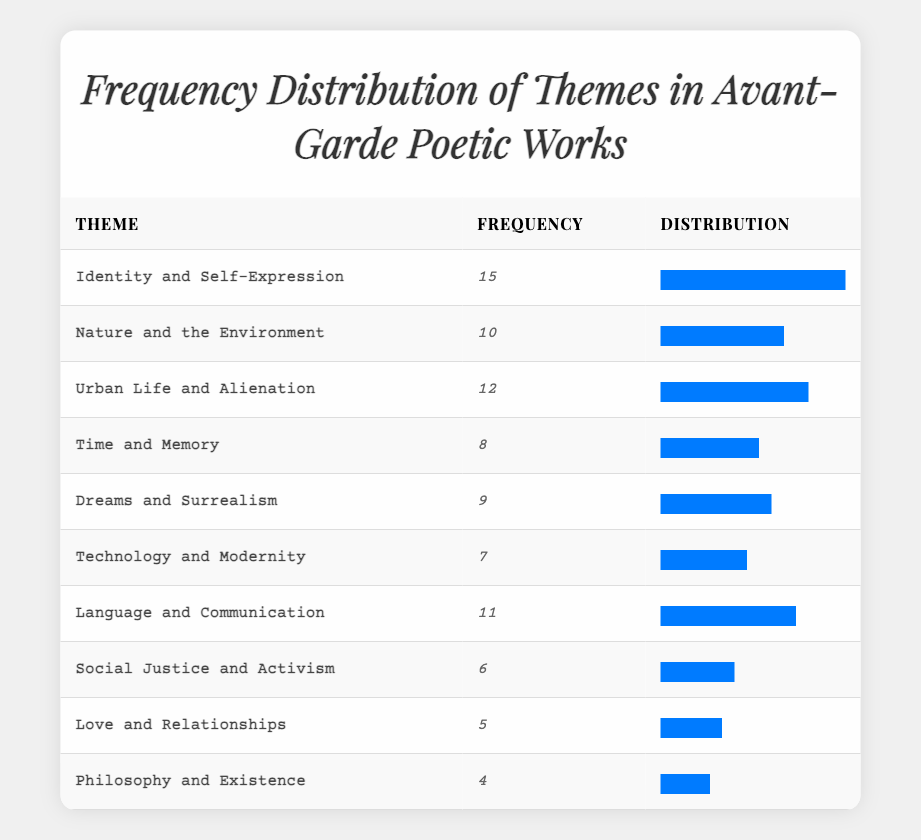What is the theme with the highest frequency in avant-garde poetic works? The table shows the frequency of various themes. Scanning the "Frequency" column, the highest value is 15, which corresponds to the theme "Identity and Self-Expression."
Answer: Identity and Self-Expression How many themes have a frequency of 10 or more? To find themes with a frequency of 10 or more, look at the frequency values listed. The themes with 10 or more frequencies are "Identity and Self-Expression" (15), "Nature and the Environment" (10), "Urban Life and Alienation" (12), "Language and Communication" (11), and "Dreams and Surrealism" (9), totaling to 5 themes.
Answer: 5 What is the total frequency of themes related to nature and urban experiences? Identify the relevant themes: "Nature and the Environment" has a frequency of 10 and "Urban Life and Alienation" has a frequency of 12. Adding these together gives 10 + 12 = 22.
Answer: 22 Is "Philosophy and Existence" one of the top three most frequent themes? Checking the frequency values, "Philosophy and Existence" has a frequency of 4. The top three themes ranked by frequency are "Identity and Self-Expression" (15), "Urban Life and Alienation" (12), and "Language and Communication" (11), so the statement is false.
Answer: No What is the difference in frequency between the most and least frequent themes? The most frequent theme is "Identity and Self-Expression" with a frequency of 15, and the least frequent theme is "Philosophy and Existence," with a frequency of 4. Calculating the difference gives 15 - 4 = 11.
Answer: 11 What is the average frequency of all themes listed? First, sum the frequencies: 15 + 10 + 12 + 8 + 9 + 7 + 11 + 6 + 5 + 4 = 87. There are 10 themes total, so the average frequency is 87 / 10 = 8.7.
Answer: 8.7 Which theme has a frequency closest to the average frequency? The average frequency is 8.7. The closest frequency values are from "Time and Memory" (8) and "Dreams and Surrealism" (9). Both are one unit away from the average.
Answer: Time and Memory and Dreams and Surrealism 